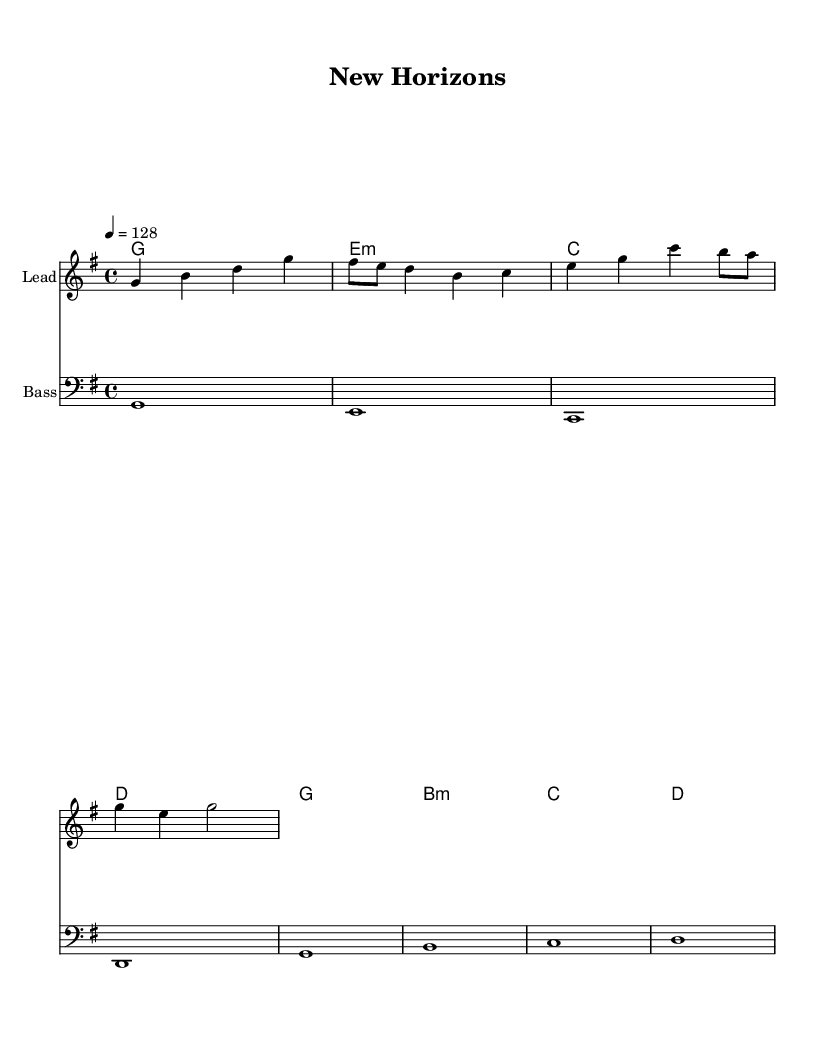What is the key signature of this music? The key signature is G major, which has one sharp (F#). This can be identified by looking at the key signature notation at the beginning of the staff.
Answer: G major What is the time signature of this music? The time signature is 4/4, which indicates that there are four beats in each measure and a quarter note receives one beat. This is shown at the beginning of the score.
Answer: 4/4 What is the tempo marking of this music? The tempo marking is 128 beats per minute, indicated by "4 = 128" at the start, where "4" refers to the quarter note and "128" indicates the speed.
Answer: 128 How many measures are in the melody? There are four measures in the melody, which can be counted by checking the vertical lines that separate the groupings of notes.
Answer: 4 Which chord is played on the first measure? The chord played on the first measure is G major, as noted in the chord names shown above the staff. The root of the chord is identified as G.
Answer: G What is the last note of the bass clef staff? The last note of the bass clef staff is D, which is indicated in the final measure of the bass part.
Answer: D What is the main theme presented in the lyrics? The main theme in the lyrics is about breaking through and stepping into the light, capturing the essence of overcoming obstacles and starting fresh, as outlined in the lyrics above the melody.
Answer: Overcoming obstacles 